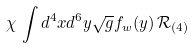<formula> <loc_0><loc_0><loc_500><loc_500>\chi \, \int d ^ { 4 } x d ^ { 6 } y \sqrt { g } f _ { w } ( y ) \, \mathcal { R } _ { ( 4 ) } \,</formula> 